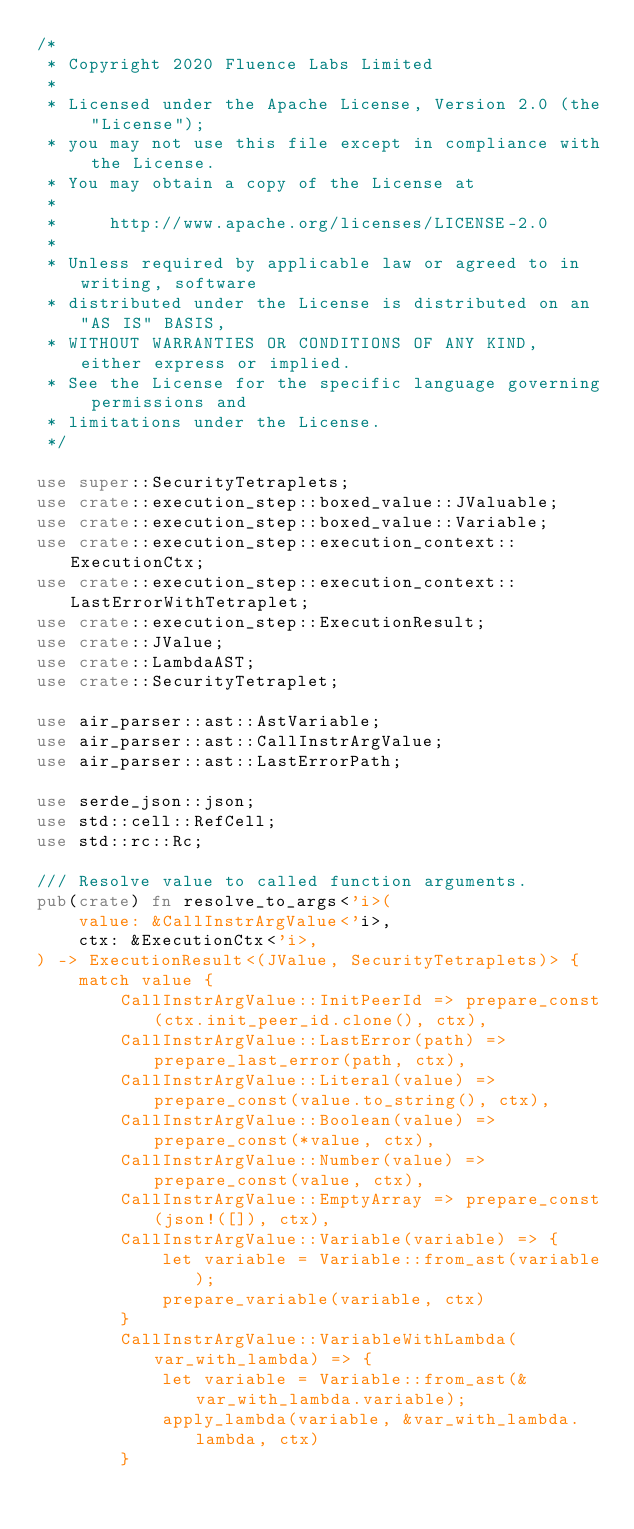<code> <loc_0><loc_0><loc_500><loc_500><_Rust_>/*
 * Copyright 2020 Fluence Labs Limited
 *
 * Licensed under the Apache License, Version 2.0 (the "License");
 * you may not use this file except in compliance with the License.
 * You may obtain a copy of the License at
 *
 *     http://www.apache.org/licenses/LICENSE-2.0
 *
 * Unless required by applicable law or agreed to in writing, software
 * distributed under the License is distributed on an "AS IS" BASIS,
 * WITHOUT WARRANTIES OR CONDITIONS OF ANY KIND, either express or implied.
 * See the License for the specific language governing permissions and
 * limitations under the License.
 */

use super::SecurityTetraplets;
use crate::execution_step::boxed_value::JValuable;
use crate::execution_step::boxed_value::Variable;
use crate::execution_step::execution_context::ExecutionCtx;
use crate::execution_step::execution_context::LastErrorWithTetraplet;
use crate::execution_step::ExecutionResult;
use crate::JValue;
use crate::LambdaAST;
use crate::SecurityTetraplet;

use air_parser::ast::AstVariable;
use air_parser::ast::CallInstrArgValue;
use air_parser::ast::LastErrorPath;

use serde_json::json;
use std::cell::RefCell;
use std::rc::Rc;

/// Resolve value to called function arguments.
pub(crate) fn resolve_to_args<'i>(
    value: &CallInstrArgValue<'i>,
    ctx: &ExecutionCtx<'i>,
) -> ExecutionResult<(JValue, SecurityTetraplets)> {
    match value {
        CallInstrArgValue::InitPeerId => prepare_const(ctx.init_peer_id.clone(), ctx),
        CallInstrArgValue::LastError(path) => prepare_last_error(path, ctx),
        CallInstrArgValue::Literal(value) => prepare_const(value.to_string(), ctx),
        CallInstrArgValue::Boolean(value) => prepare_const(*value, ctx),
        CallInstrArgValue::Number(value) => prepare_const(value, ctx),
        CallInstrArgValue::EmptyArray => prepare_const(json!([]), ctx),
        CallInstrArgValue::Variable(variable) => {
            let variable = Variable::from_ast(variable);
            prepare_variable(variable, ctx)
        }
        CallInstrArgValue::VariableWithLambda(var_with_lambda) => {
            let variable = Variable::from_ast(&var_with_lambda.variable);
            apply_lambda(variable, &var_with_lambda.lambda, ctx)
        }</code> 